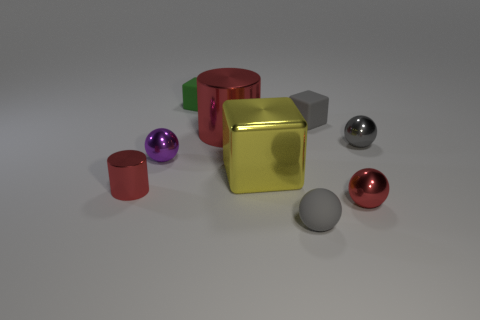How would you describe the arrangement of the different shapes visible? The shapes are arranged in no specific pattern, featuring a mix of geometrical solids, including spheres, cylinders, and cubes, each with a different material and color finish. Can you tell me which of these shapes are not spheres? Certainly! The non-spherical shapes include a gold cube near the center, a green cylinder to the left, a grey cube to the right, and a red cylinder towards the back. 